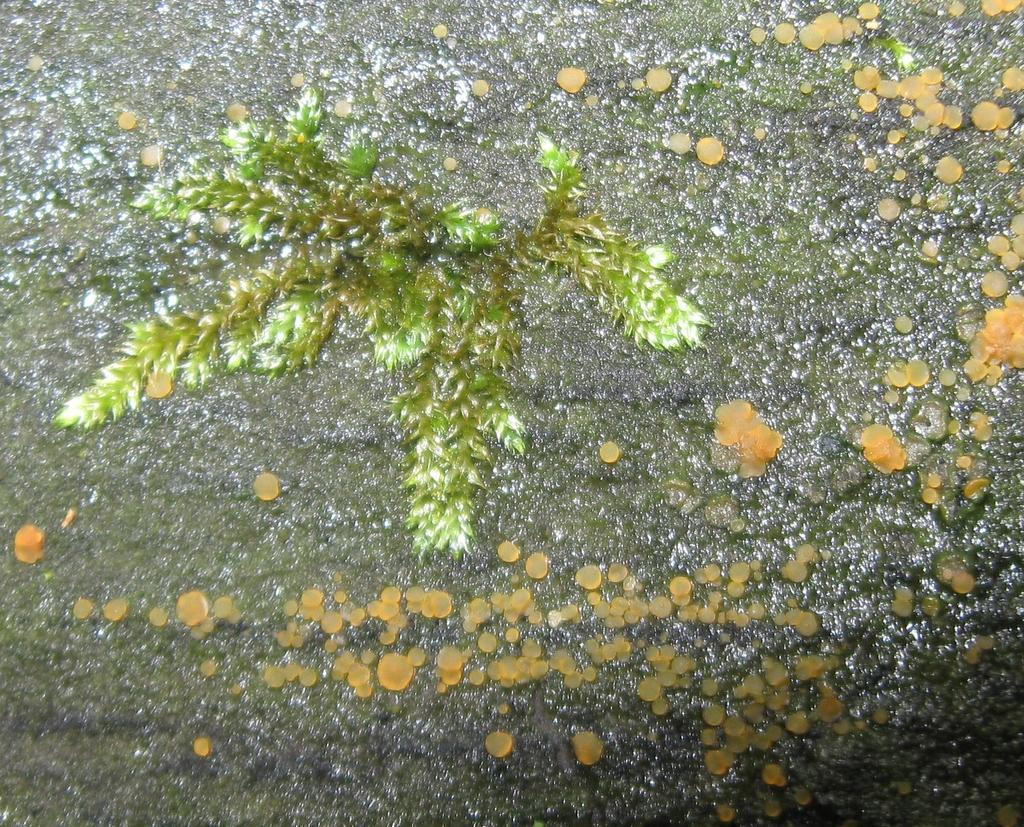Could you give a brief overview of what you see in this image? On this rock we can see the formation of algae and plant.  